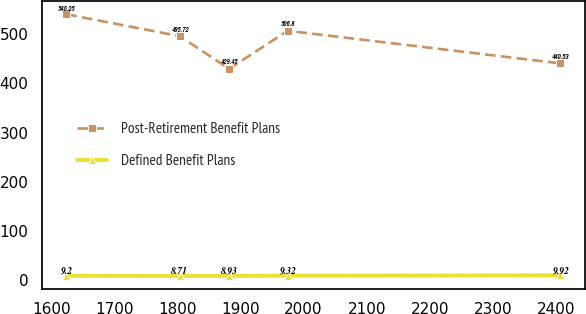Convert chart. <chart><loc_0><loc_0><loc_500><loc_500><line_chart><ecel><fcel>Post-Retirement Benefit Plans<fcel>Defined Benefit Plans<nl><fcel>1624.05<fcel>540.25<fcel>9.2<nl><fcel>1803.82<fcel>495.72<fcel>8.71<nl><fcel>1882.06<fcel>429.45<fcel>8.93<nl><fcel>1974.74<fcel>506.8<fcel>9.32<nl><fcel>2406.49<fcel>440.53<fcel>9.92<nl></chart> 